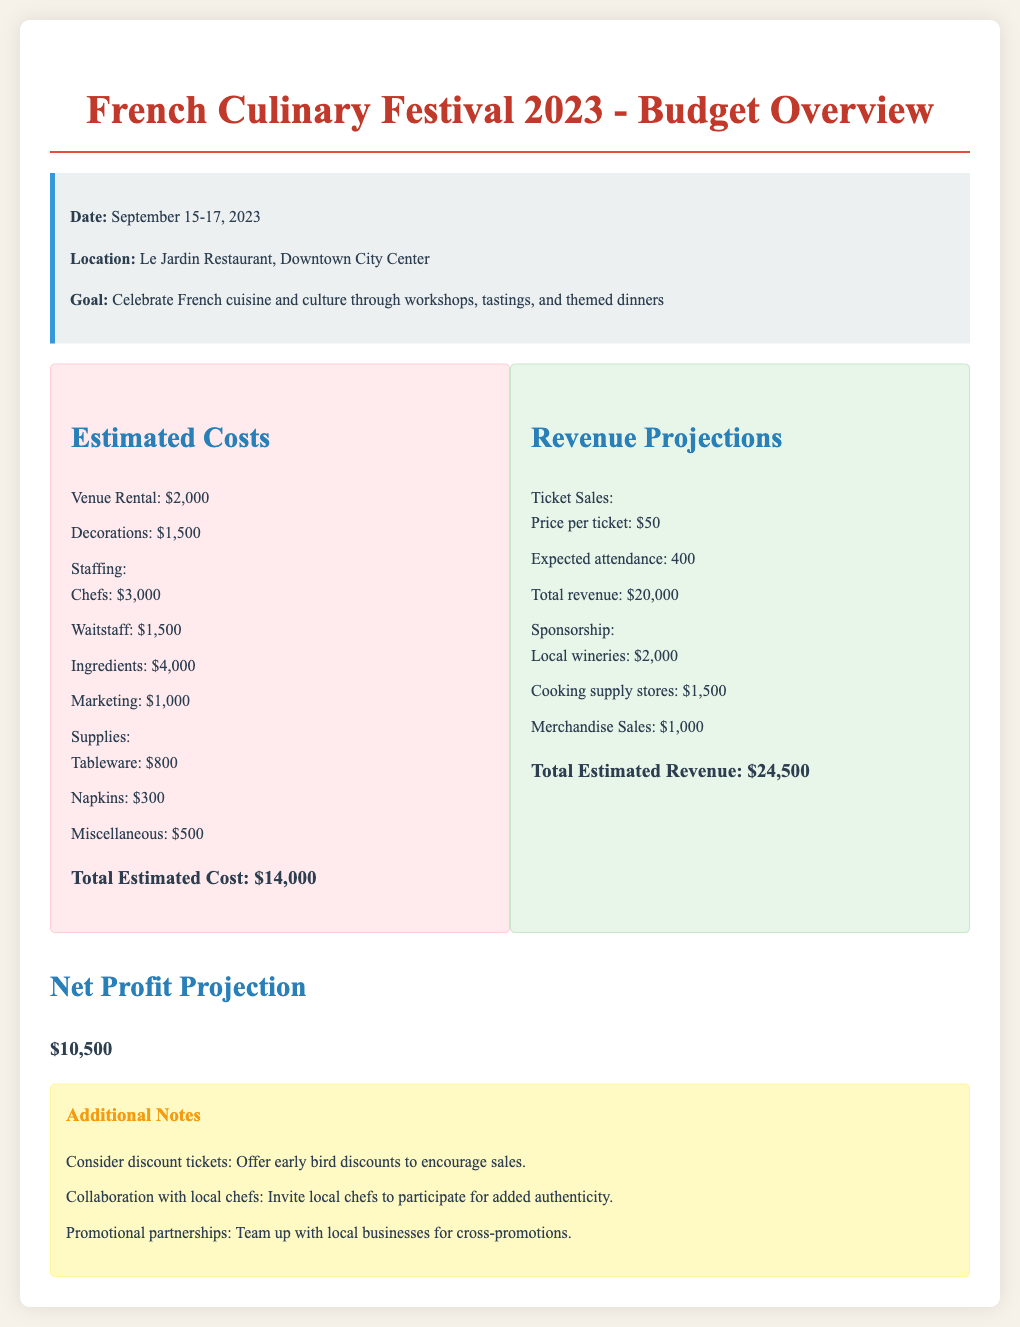What are the festival dates? The festival dates are provided in the document as September 15-17, 2023.
Answer: September 15-17, 2023 What is the total estimated cost? The total estimated cost is mentioned in the document as $14,000.
Answer: $14,000 How much revenue is expected from ticket sales? The total revenue from ticket sales is calculated based on the price per ticket and expected attendance, resulting in $20,000.
Answer: $20,000 What is the net profit projection? The net profit projection is stated in the document as the difference between total estimated revenue and total estimated cost, which is $10,500.
Answer: $10,500 How many local wineries are sponsoring the event? The document lists the local wineries contributing $2,000, indicating there are multiple sponsors, but does not specify a number.
Answer: $2,000 What is the estimated cost for staffing? The combined estimated cost for chefs and waitstaff as per the document totals $4,500.
Answer: $4,500 What is the decoration budget? The decoration budget is specified as $1,500 in the estimated costs section.
Answer: $1,500 What additional ticket feature is suggested? The document suggests offering early bird discounts for ticket sales.
Answer: Early bird discounts What is the venue for the festival? The venue for the festival is noted in the document as Le Jardin Restaurant, Downtown City Center.
Answer: Le Jardin Restaurant, Downtown City Center What is the revenue projection from merchandise sales? According to the document, the revenue from merchandise sales is estimated to be $1,000.
Answer: $1,000 